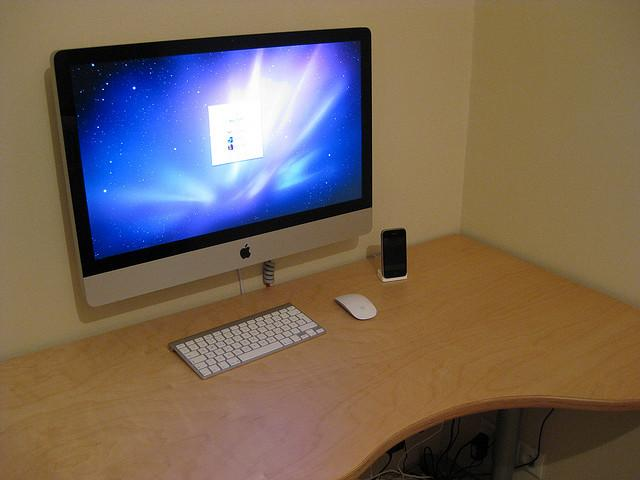What is on the desk? keyboard 